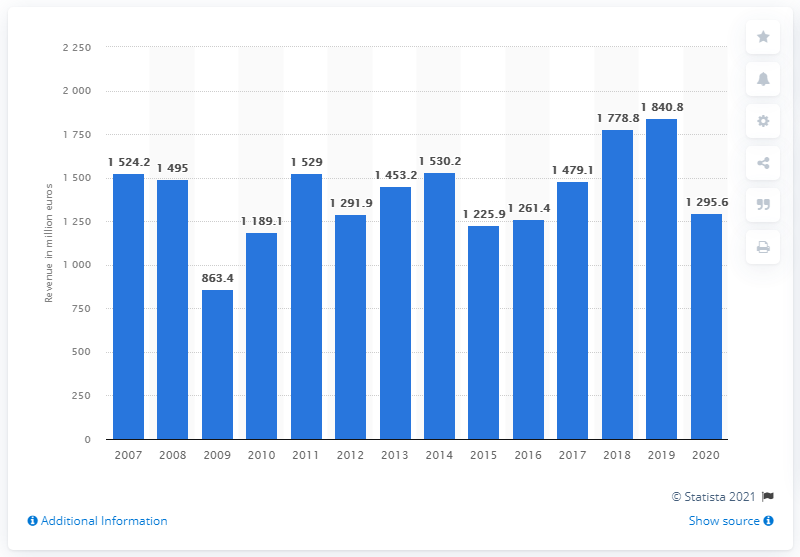Specify some key components in this picture. In the fiscal year of 2020, Deutz AG's global revenue was 1,295.6 million USD. 